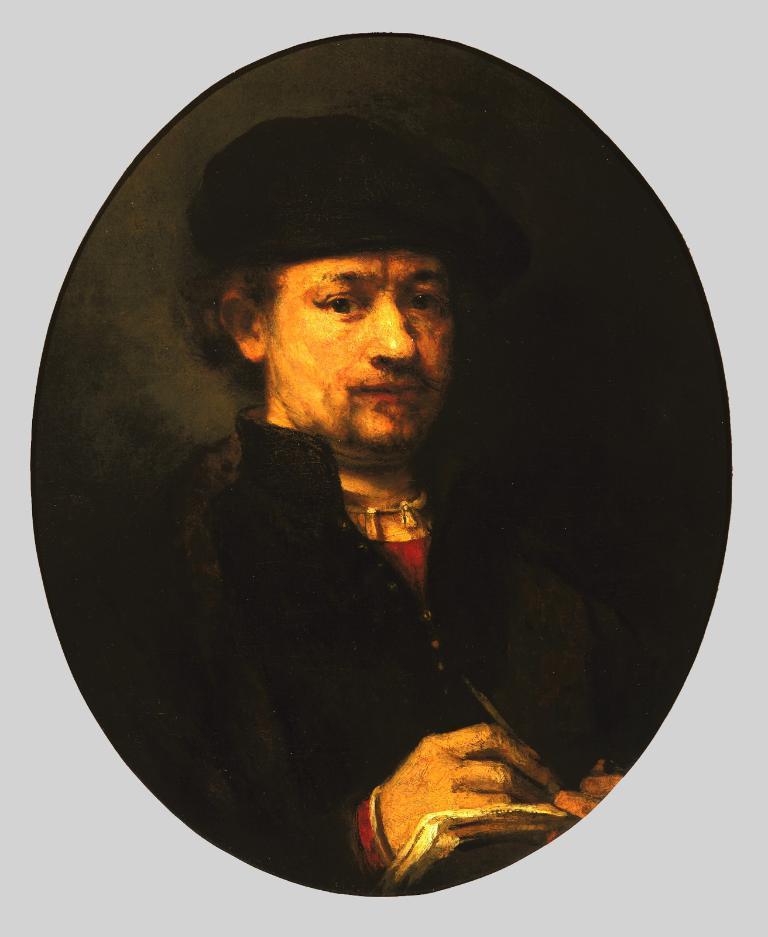Can you describe this image briefly? In this image there is a photo of a person holding a book and a pen. 